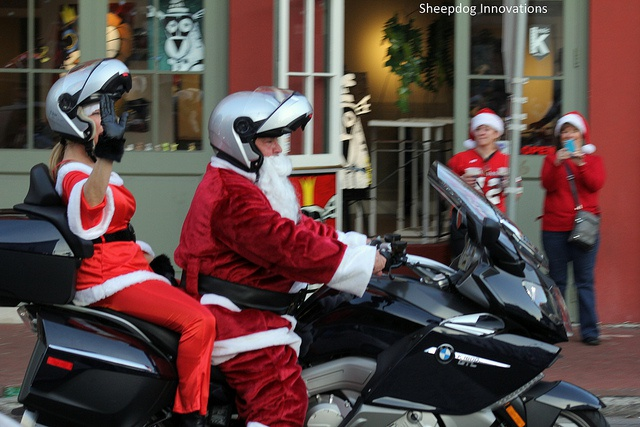Describe the objects in this image and their specific colors. I can see motorcycle in black, gray, darkblue, and darkgray tones, people in black, maroon, brown, and lightgray tones, people in black, red, brown, and lightgray tones, people in black, brown, maroon, and gray tones, and people in black, brown, and darkgray tones in this image. 